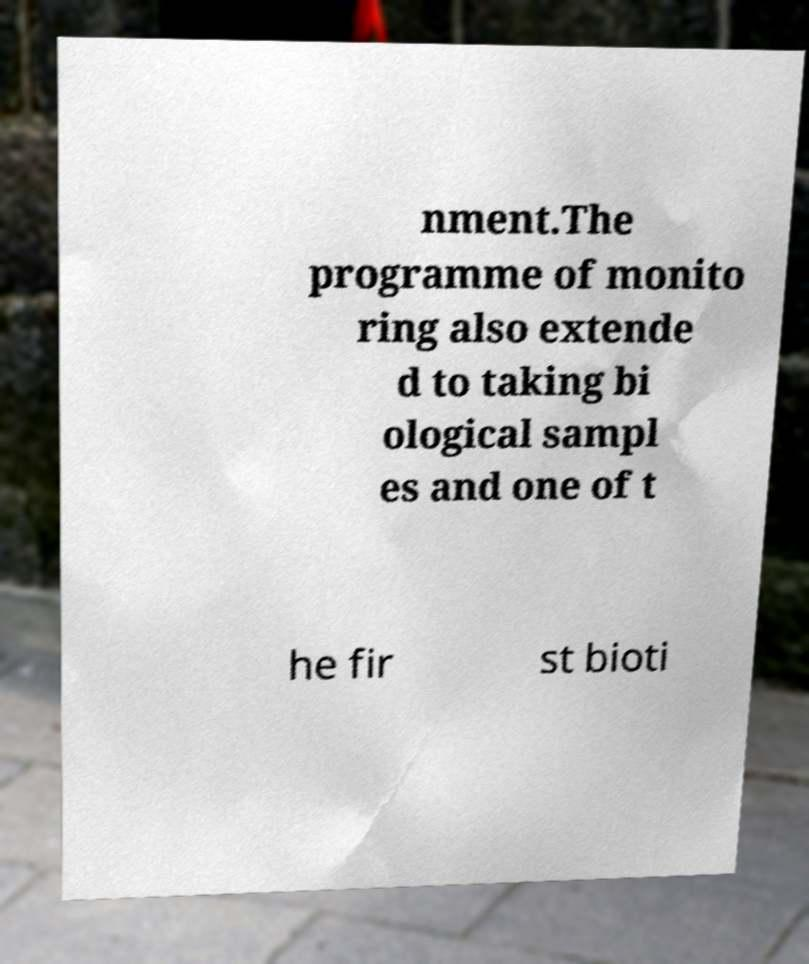Can you read and provide the text displayed in the image?This photo seems to have some interesting text. Can you extract and type it out for me? nment.The programme of monito ring also extende d to taking bi ological sampl es and one of t he fir st bioti 